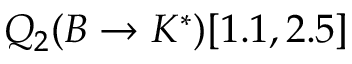Convert formula to latex. <formula><loc_0><loc_0><loc_500><loc_500>Q _ { 2 } ( B \to K ^ { * } ) [ 1 . 1 , 2 . 5 ]</formula> 